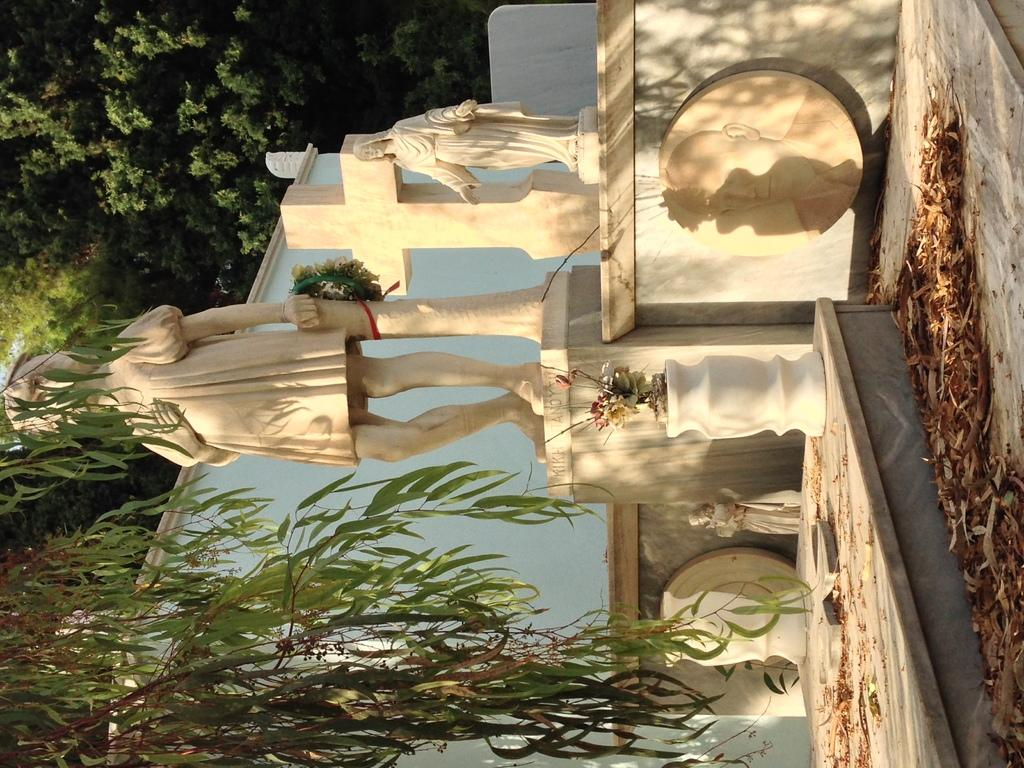What type of objects can be seen in the image? There are statues in the image. What is located in the center of the image? There is a flower pot in the center of the image. What can be seen in the background of the image? There are trees in the background of the image. What is the wealth status of the person who sneezed in the image? There is no person sneezing in the image, and therefore no wealth status can be determined. 